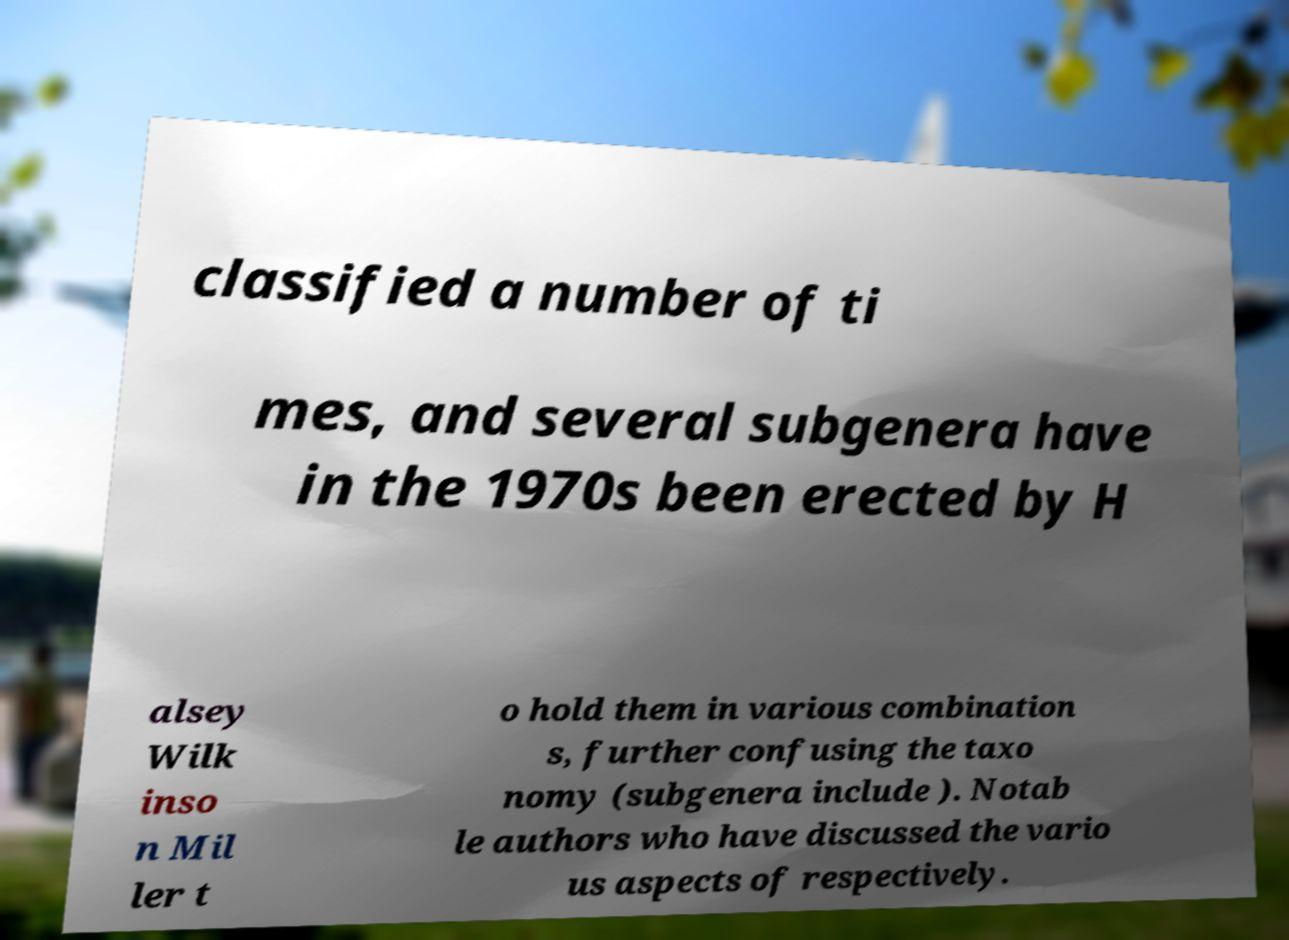Can you read and provide the text displayed in the image?This photo seems to have some interesting text. Can you extract and type it out for me? classified a number of ti mes, and several subgenera have in the 1970s been erected by H alsey Wilk inso n Mil ler t o hold them in various combination s, further confusing the taxo nomy (subgenera include ). Notab le authors who have discussed the vario us aspects of respectively. 